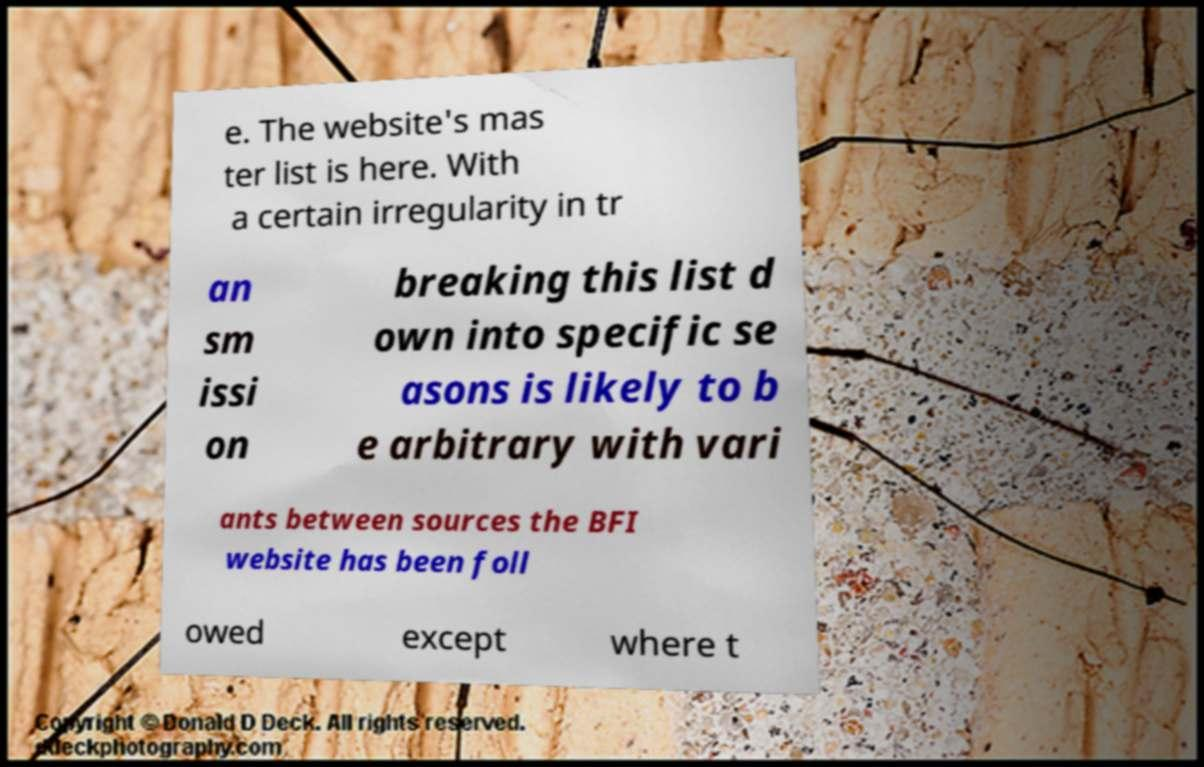Can you accurately transcribe the text from the provided image for me? e. The website's mas ter list is here. With a certain irregularity in tr an sm issi on breaking this list d own into specific se asons is likely to b e arbitrary with vari ants between sources the BFI website has been foll owed except where t 